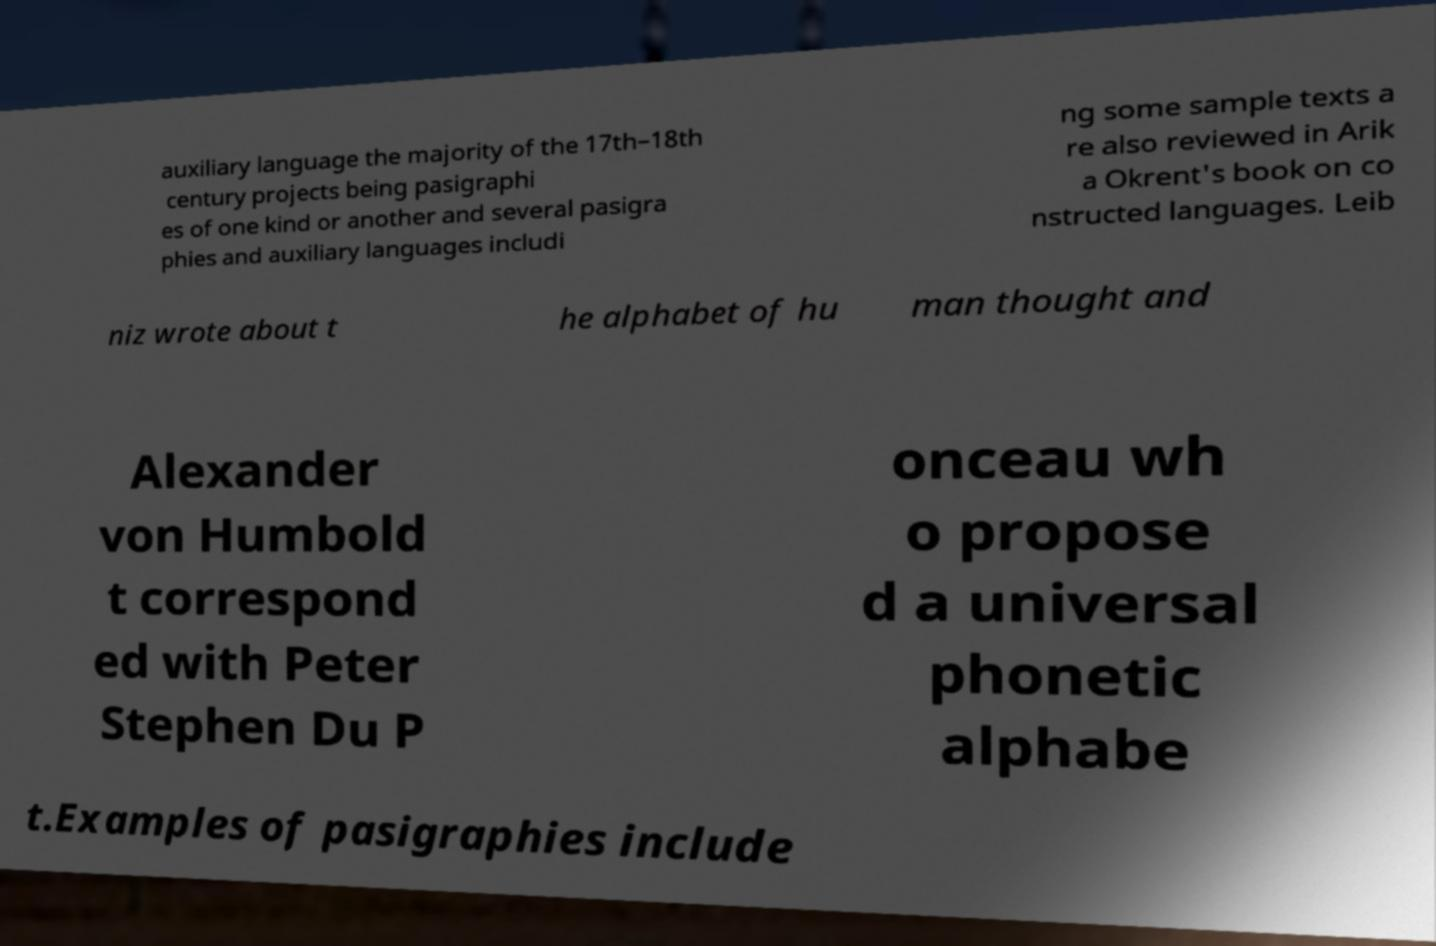For documentation purposes, I need the text within this image transcribed. Could you provide that? auxiliary language the majority of the 17th–18th century projects being pasigraphi es of one kind or another and several pasigra phies and auxiliary languages includi ng some sample texts a re also reviewed in Arik a Okrent's book on co nstructed languages. Leib niz wrote about t he alphabet of hu man thought and Alexander von Humbold t correspond ed with Peter Stephen Du P onceau wh o propose d a universal phonetic alphabe t.Examples of pasigraphies include 